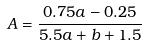Convert formula to latex. <formula><loc_0><loc_0><loc_500><loc_500>A = \frac { 0 . 7 5 a - 0 . 2 5 } { 5 . 5 a + b + 1 . 5 }</formula> 